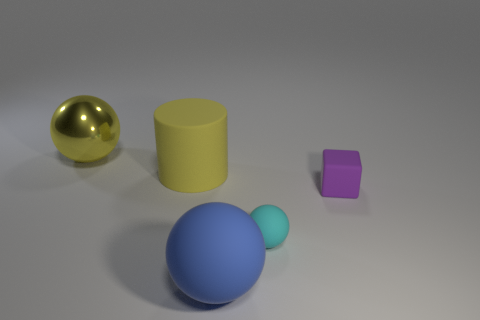Add 4 blue rubber spheres. How many objects exist? 9 Subtract all balls. How many objects are left? 2 Subtract 0 yellow cubes. How many objects are left? 5 Subtract all yellow shiny balls. Subtract all yellow cylinders. How many objects are left? 3 Add 5 yellow cylinders. How many yellow cylinders are left? 6 Add 3 big yellow metal things. How many big yellow metal things exist? 4 